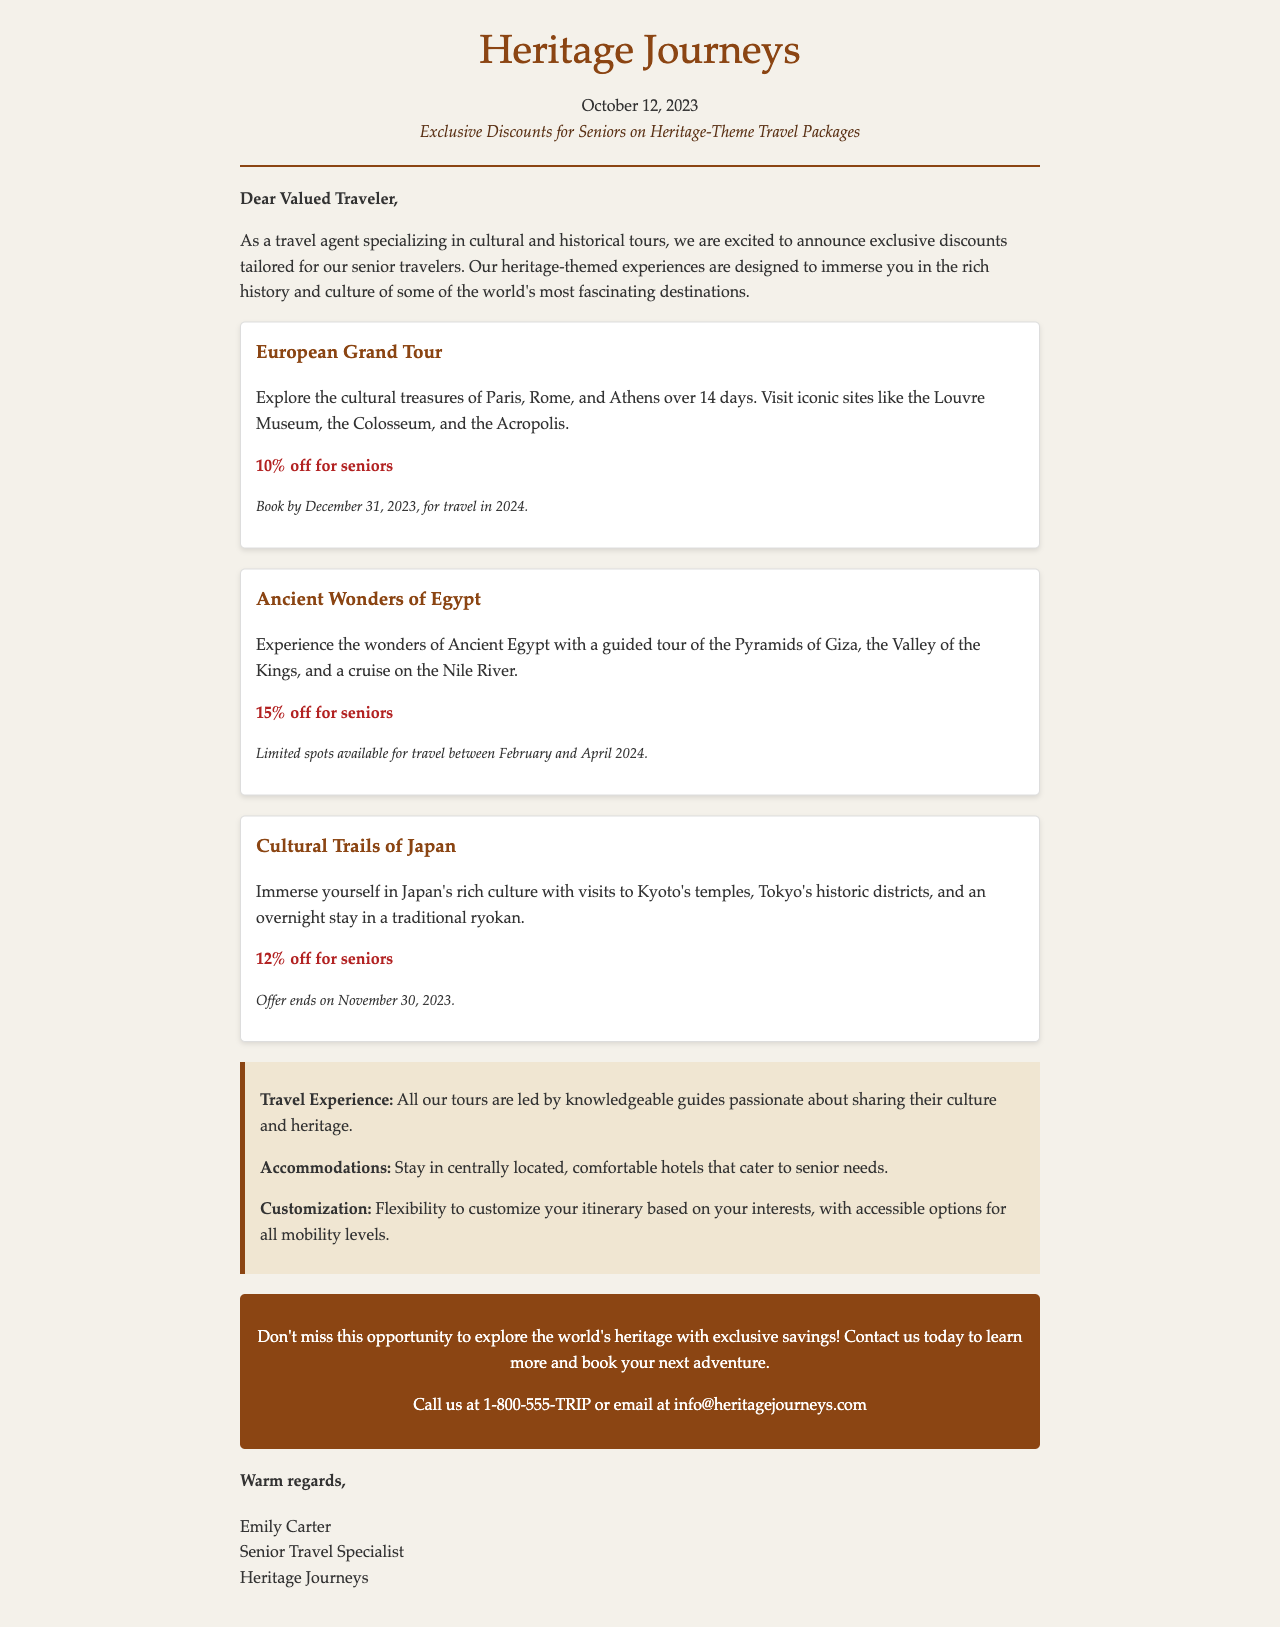What is the name of the company? The company name is prominently displayed at the top of the letter.
Answer: Heritage Journeys What date was the letter sent? The date is specified under the company name in the header section of the letter.
Answer: October 12, 2023 What discount is offered for the European Grand Tour package? The discount is mentioned in the description of the package.
Answer: 10% off for seniors What is the validity date for booking the Ancient Wonders of Egypt package? The validity is indicated in the package details.
Answer: Limited spots available for travel between February and April 2024 Who is the sender of the letter? The signature at the bottom of the letter provides the name of the sender.
Answer: Emily Carter What is one benefit listed for the tours? The benefits section outlines several advantages of the tours, one of which is specifically highlighted.
Answer: Knowledgeable guides What is the maximum number of days for the European Grand Tour? The duration of the tour is mentioned in the package description.
Answer: 14 days What is the end date for the Cultural Trails of Japan offer? The end date is specified in the offer details.
Answer: November 30, 2023 How can potential travelers contact the company? The contact information is provided in the call-to-action section.
Answer: 1-800-555-TRIP or email at info@heritagejourneys.com 